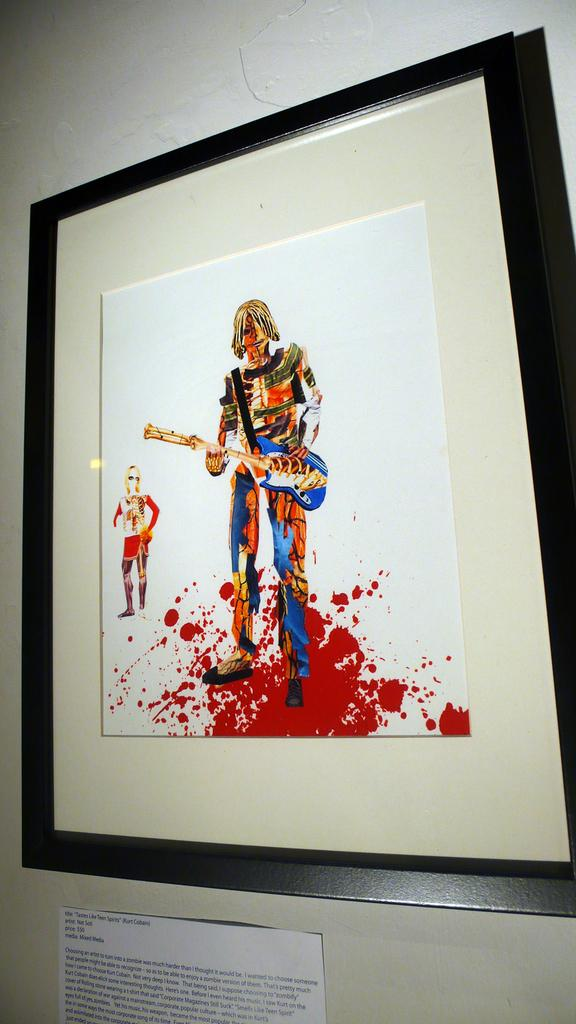What type of artwork is depicted in the image? There is a painted photo in the image. How is the painted photo displayed? The painted photo is framed and attached to the wall. What else can be seen on the wall in the image? There is a paper on the wall. What type of line is used to create motion in the image? There is no line or motion present in the image; it features a painted photo in a frame attached to the wall and a paper on the wall. 